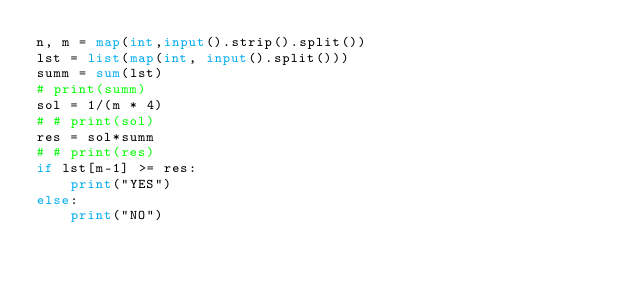Convert code to text. <code><loc_0><loc_0><loc_500><loc_500><_Python_>n, m = map(int,input().strip().split())
lst = list(map(int, input().split()))
summ = sum(lst)
# print(summ)
sol = 1/(m * 4)
# # print(sol)
res = sol*summ
# # print(res)
if lst[m-1] >= res:
    print("YES")
else:
    print("NO")</code> 